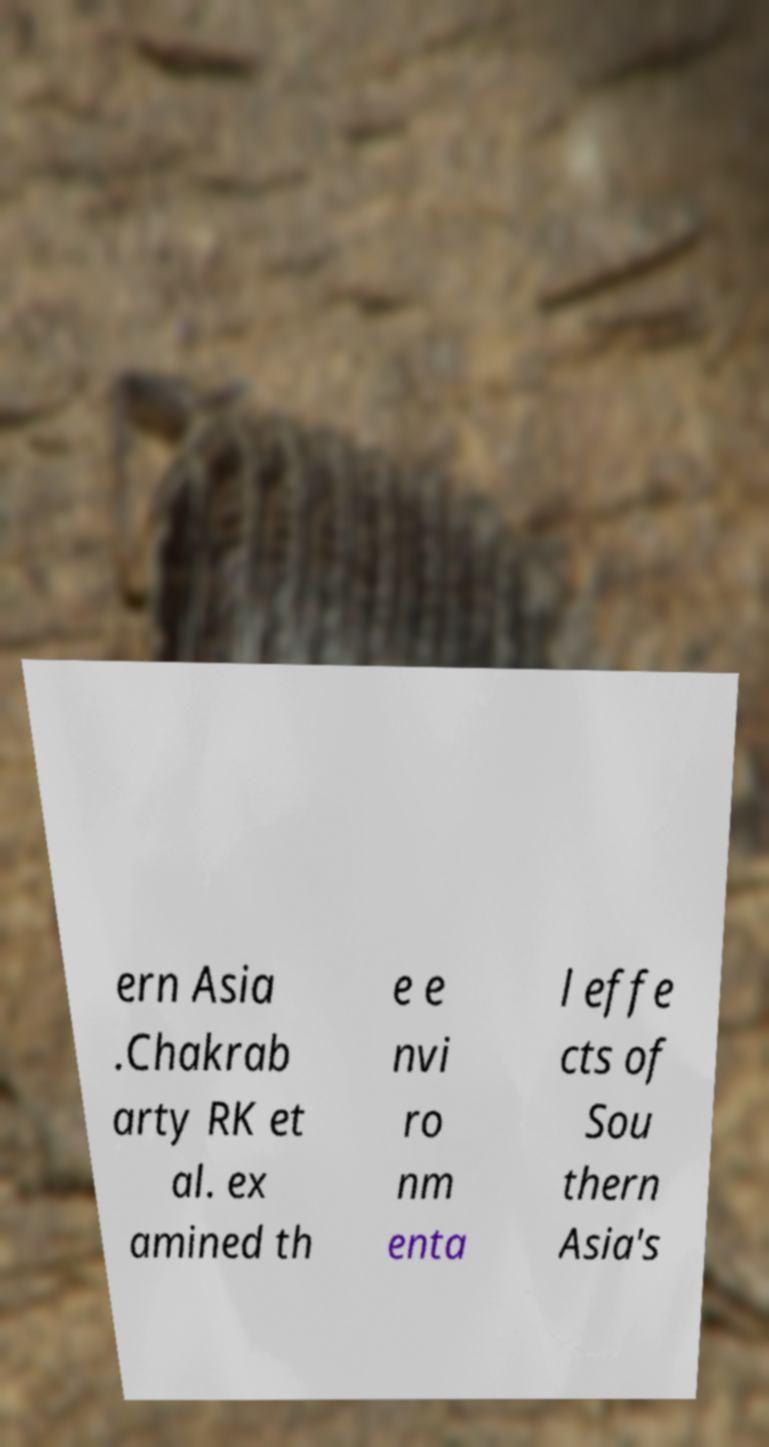For documentation purposes, I need the text within this image transcribed. Could you provide that? ern Asia .Chakrab arty RK et al. ex amined th e e nvi ro nm enta l effe cts of Sou thern Asia's 